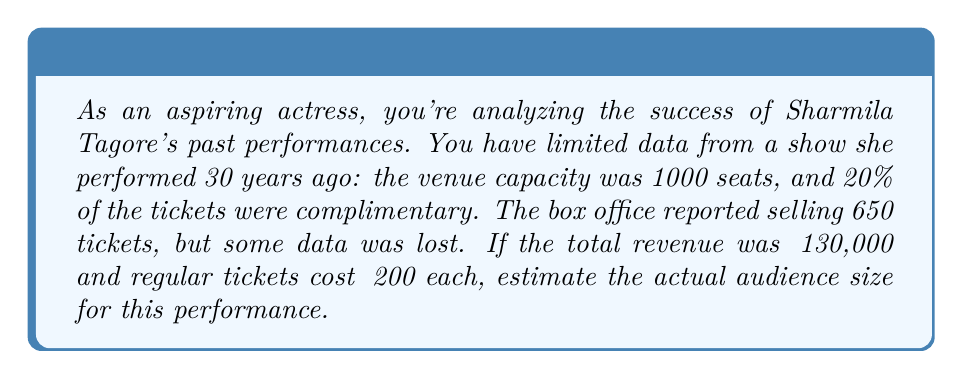Teach me how to tackle this problem. Let's approach this step-by-step:

1) First, let's define our variables:
   $x$ = number of regular (paid) tickets
   $y$ = number of complimentary tickets
   $z$ = total audience size

2) We know that 20% of the tickets were complimentary. This means:
   $y = 0.2z$

3) We also know that the total audience size is the sum of paid and complimentary tickets:
   $z = x + y$

4) Substituting (2) into (3):
   $z = x + 0.2z$
   $0.8z = x$
   $x = 0.8z$

5) Now, we know the revenue was ₹130,000 and each ticket cost ₹200. So:
   $200x = 130000$
   $x = 650$

6) Using the relation from step 4:
   $650 = 0.8z$
   $z = 650 / 0.8 = 812.5$

7) Since we can't have a fractional audience member, we round up to 813.

8) To verify:
   Paid tickets: $813 * 0.8 = 650.4$ ≈ 650
   Complimentary tickets: $813 * 0.2 = 162.6$ ≈ 163
   650 + 163 = 813

Therefore, the estimated audience size is 813 people.
Answer: 813 people 